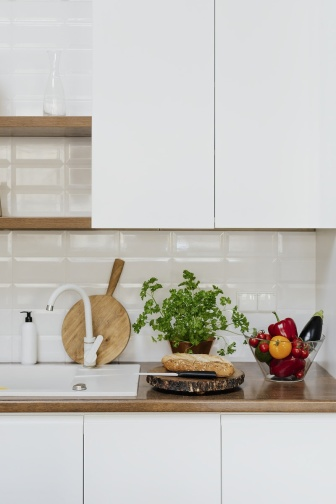How would this kitchen function in a high-paced, professional environment? In a high-paced, professional environment, the kitchen's sleek and organized design would greatly facilitate efficiency and workflow. The clean and minimalistic layout of the countertop allows for easy and quick preparation of ingredients, while the ample space ensures that various cooking tasks can be performed simultaneously. The modern faucet and strategically placed sink enable swift cleaning and washing of utensils. The presence of fresh herbs and fruits enhances the culinary experience, providing chefs with readily accessible ingredients for creative dishes. Overall, the kitchen would support a dynamic and efficient culinary environment, ideal for professional chefs. What seasonal decorations would fit well in this kitchen? For the fall season, a few subtle yet festive additions like a decorative gourd or small pumpkin on the countertop would complement the kitchen's natural tones. Thanksgiving-themed placemats or a small vase with autumnal flowers could add a seasonal touch. In winter, consider incorporating a small bowl of pinecones, holiday-themed towels, or a few sprigs of holly around the sink area to bring a cozy and festive atmosphere. Spring and summer could introduce vibrant and fresh elements such as a vase of blooming flowers or a bowl of brightly colored seasonal fruits, enhancing the kitchen's vibrant and lively aesthetic. 